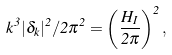Convert formula to latex. <formula><loc_0><loc_0><loc_500><loc_500>k ^ { 3 } | \delta _ { k } | ^ { 2 } / 2 \pi ^ { 2 } = \left ( \frac { H _ { I } } { 2 \pi } \right ) ^ { 2 } ,</formula> 